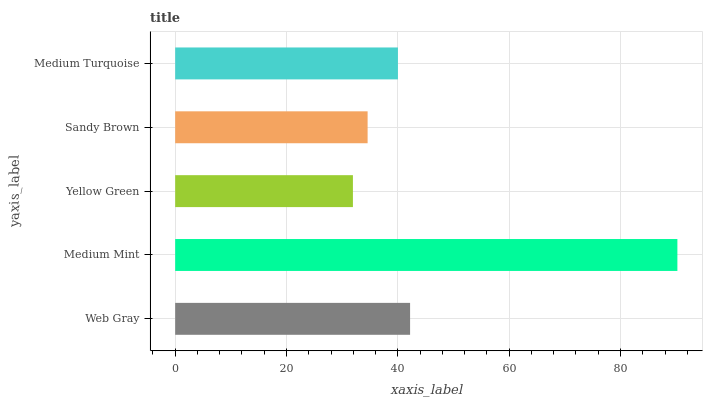Is Yellow Green the minimum?
Answer yes or no. Yes. Is Medium Mint the maximum?
Answer yes or no. Yes. Is Medium Mint the minimum?
Answer yes or no. No. Is Yellow Green the maximum?
Answer yes or no. No. Is Medium Mint greater than Yellow Green?
Answer yes or no. Yes. Is Yellow Green less than Medium Mint?
Answer yes or no. Yes. Is Yellow Green greater than Medium Mint?
Answer yes or no. No. Is Medium Mint less than Yellow Green?
Answer yes or no. No. Is Medium Turquoise the high median?
Answer yes or no. Yes. Is Medium Turquoise the low median?
Answer yes or no. Yes. Is Medium Mint the high median?
Answer yes or no. No. Is Yellow Green the low median?
Answer yes or no. No. 